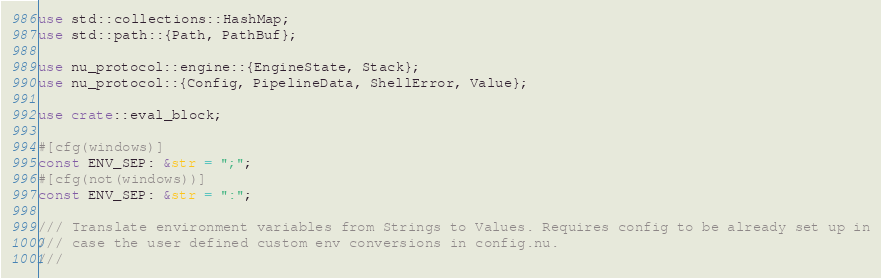<code> <loc_0><loc_0><loc_500><loc_500><_Rust_>use std::collections::HashMap;
use std::path::{Path, PathBuf};

use nu_protocol::engine::{EngineState, Stack};
use nu_protocol::{Config, PipelineData, ShellError, Value};

use crate::eval_block;

#[cfg(windows)]
const ENV_SEP: &str = ";";
#[cfg(not(windows))]
const ENV_SEP: &str = ":";

/// Translate environment variables from Strings to Values. Requires config to be already set up in
/// case the user defined custom env conversions in config.nu.
///</code> 